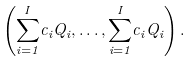<formula> <loc_0><loc_0><loc_500><loc_500>\left ( { \sum _ { i = 1 } ^ { I } } c _ { i } Q _ { i } , \dots , { \sum _ { i = 1 } ^ { I } } c _ { i } Q _ { i } \right ) .</formula> 